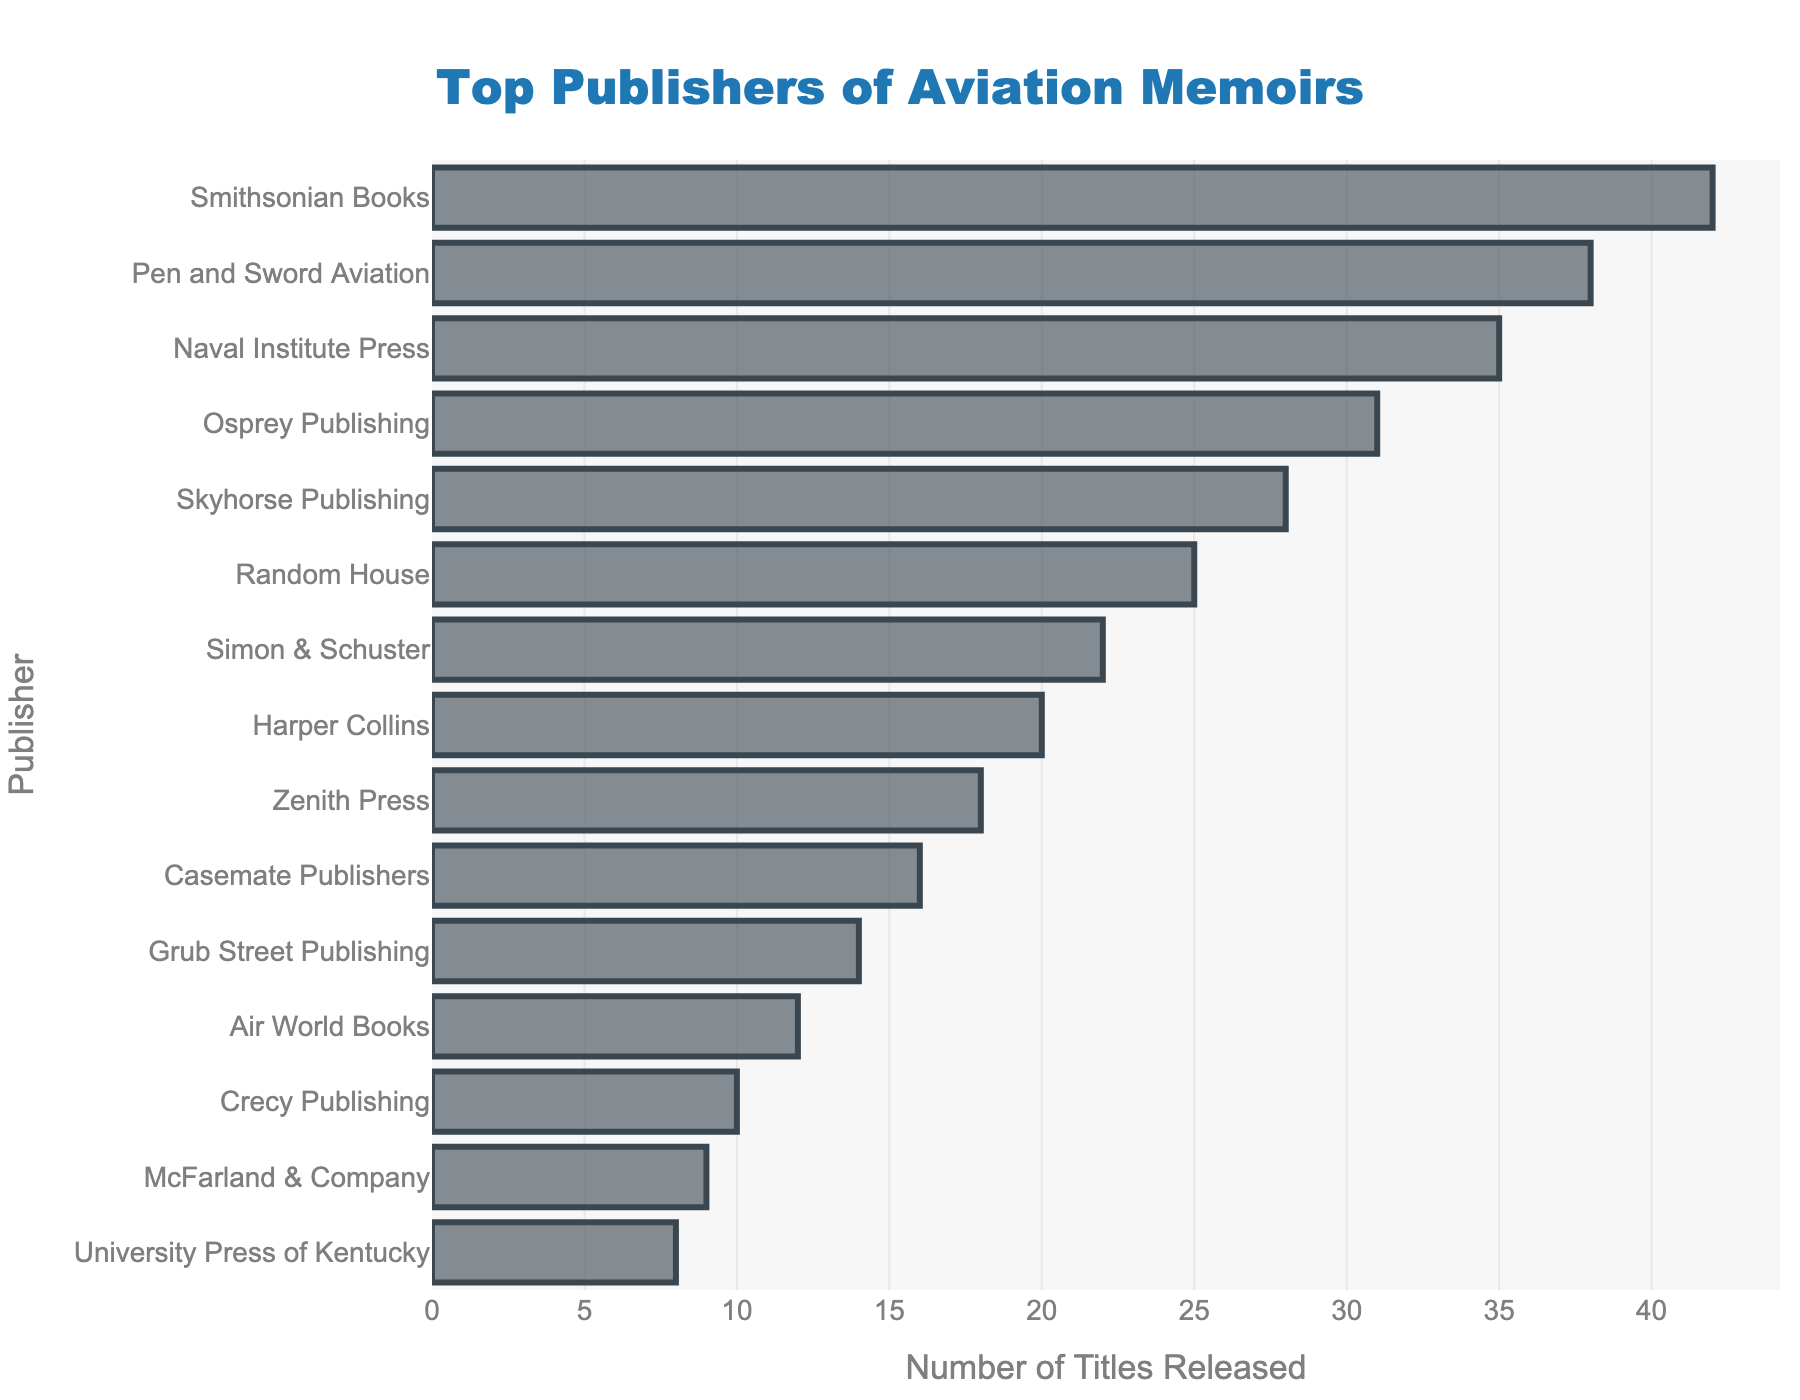What is the total number of titles released by the top 3 publishers? Calculate the sum of titles released by Smithsonian Books, Pen and Sword Aviation, and Naval Institute Press: 42 + 38 + 35.
Answer: 115 Which publisher has released more titles, Skyhorse Publishing or Random House? Compare the number of titles released by Skyhorse Publishing (28) and Random House (25).
Answer: Skyhorse Publishing How many more titles has Smithsonian Books released compared to Grub Street Publishing? Subtract the number of titles released by Grub Street Publishing (14) from Smithsonian Books (42): 42 - 14.
Answer: 28 What is the average number of titles released by all publishers? Sum all titles released: 42 + 38 + 35 + 31 + 28 + 25 + 22 + 20 + 18 + 16 + 14 + 12 + 10 + 9 + 8 = 328. Divide by the number of publishers: 328 / 15.
Answer: 21.87 Which publisher is ranked third in terms of the number of titles released? Identify the publisher with the third highest number of titles based on visual ranking: Naval Institute Press with 35 titles.
Answer: Naval Institute Press What is the difference in the number of titles between the publisher with the most and the publisher with the least titles? Subtract the number of titles by the publisher with the least (University Press of Kentucky, 8) from the number of titles by the publisher with the most (Smithsonian Books, 42): 42 - 8.
Answer: 34 Which publisher has released fewer titles, Harper Collins or Zenith Press? Compare the number of titles released by Harper Collins (20) and Zenith Press (18).
Answer: Zenith Press How many publishers have released at least 30 titles? Count the number of publishers that have 30 or more titles: Smithsonian Books (42), Pen and Sword Aviation (38), Naval Institute Press (35), Osprey Publishing (31), total is 4.
Answer: 4 What is the median number of titles released by the publishers? Sort the number of titles released in ascending order and find the middle value. Sorted values: 8, 9, 10, 12, 14, 16, 18, 20, 22, 25, 28, 31, 35, 38, 42. The middle is: 22.
Answer: 22 